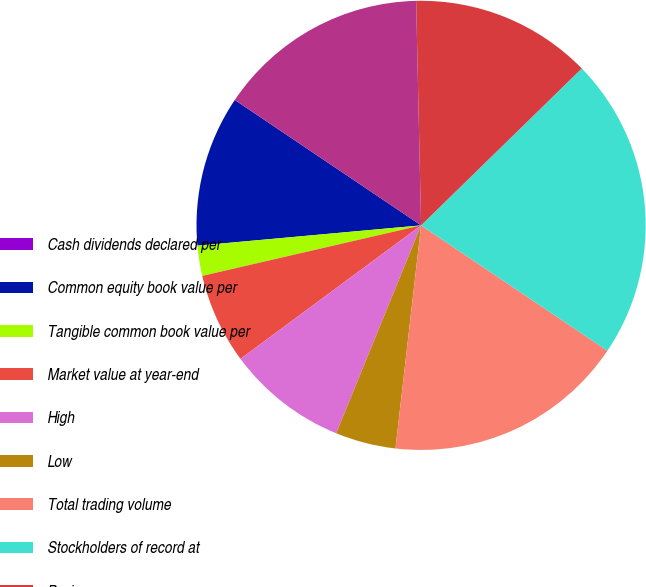Convert chart to OTSL. <chart><loc_0><loc_0><loc_500><loc_500><pie_chart><fcel>Cash dividends declared per<fcel>Common equity book value per<fcel>Tangible common book value per<fcel>Market value at year-end<fcel>High<fcel>Low<fcel>Total trading volume<fcel>Stockholders of record at<fcel>Basic<fcel>Diluted<nl><fcel>0.0%<fcel>10.87%<fcel>2.17%<fcel>6.52%<fcel>8.7%<fcel>4.35%<fcel>17.39%<fcel>21.74%<fcel>13.04%<fcel>15.22%<nl></chart> 